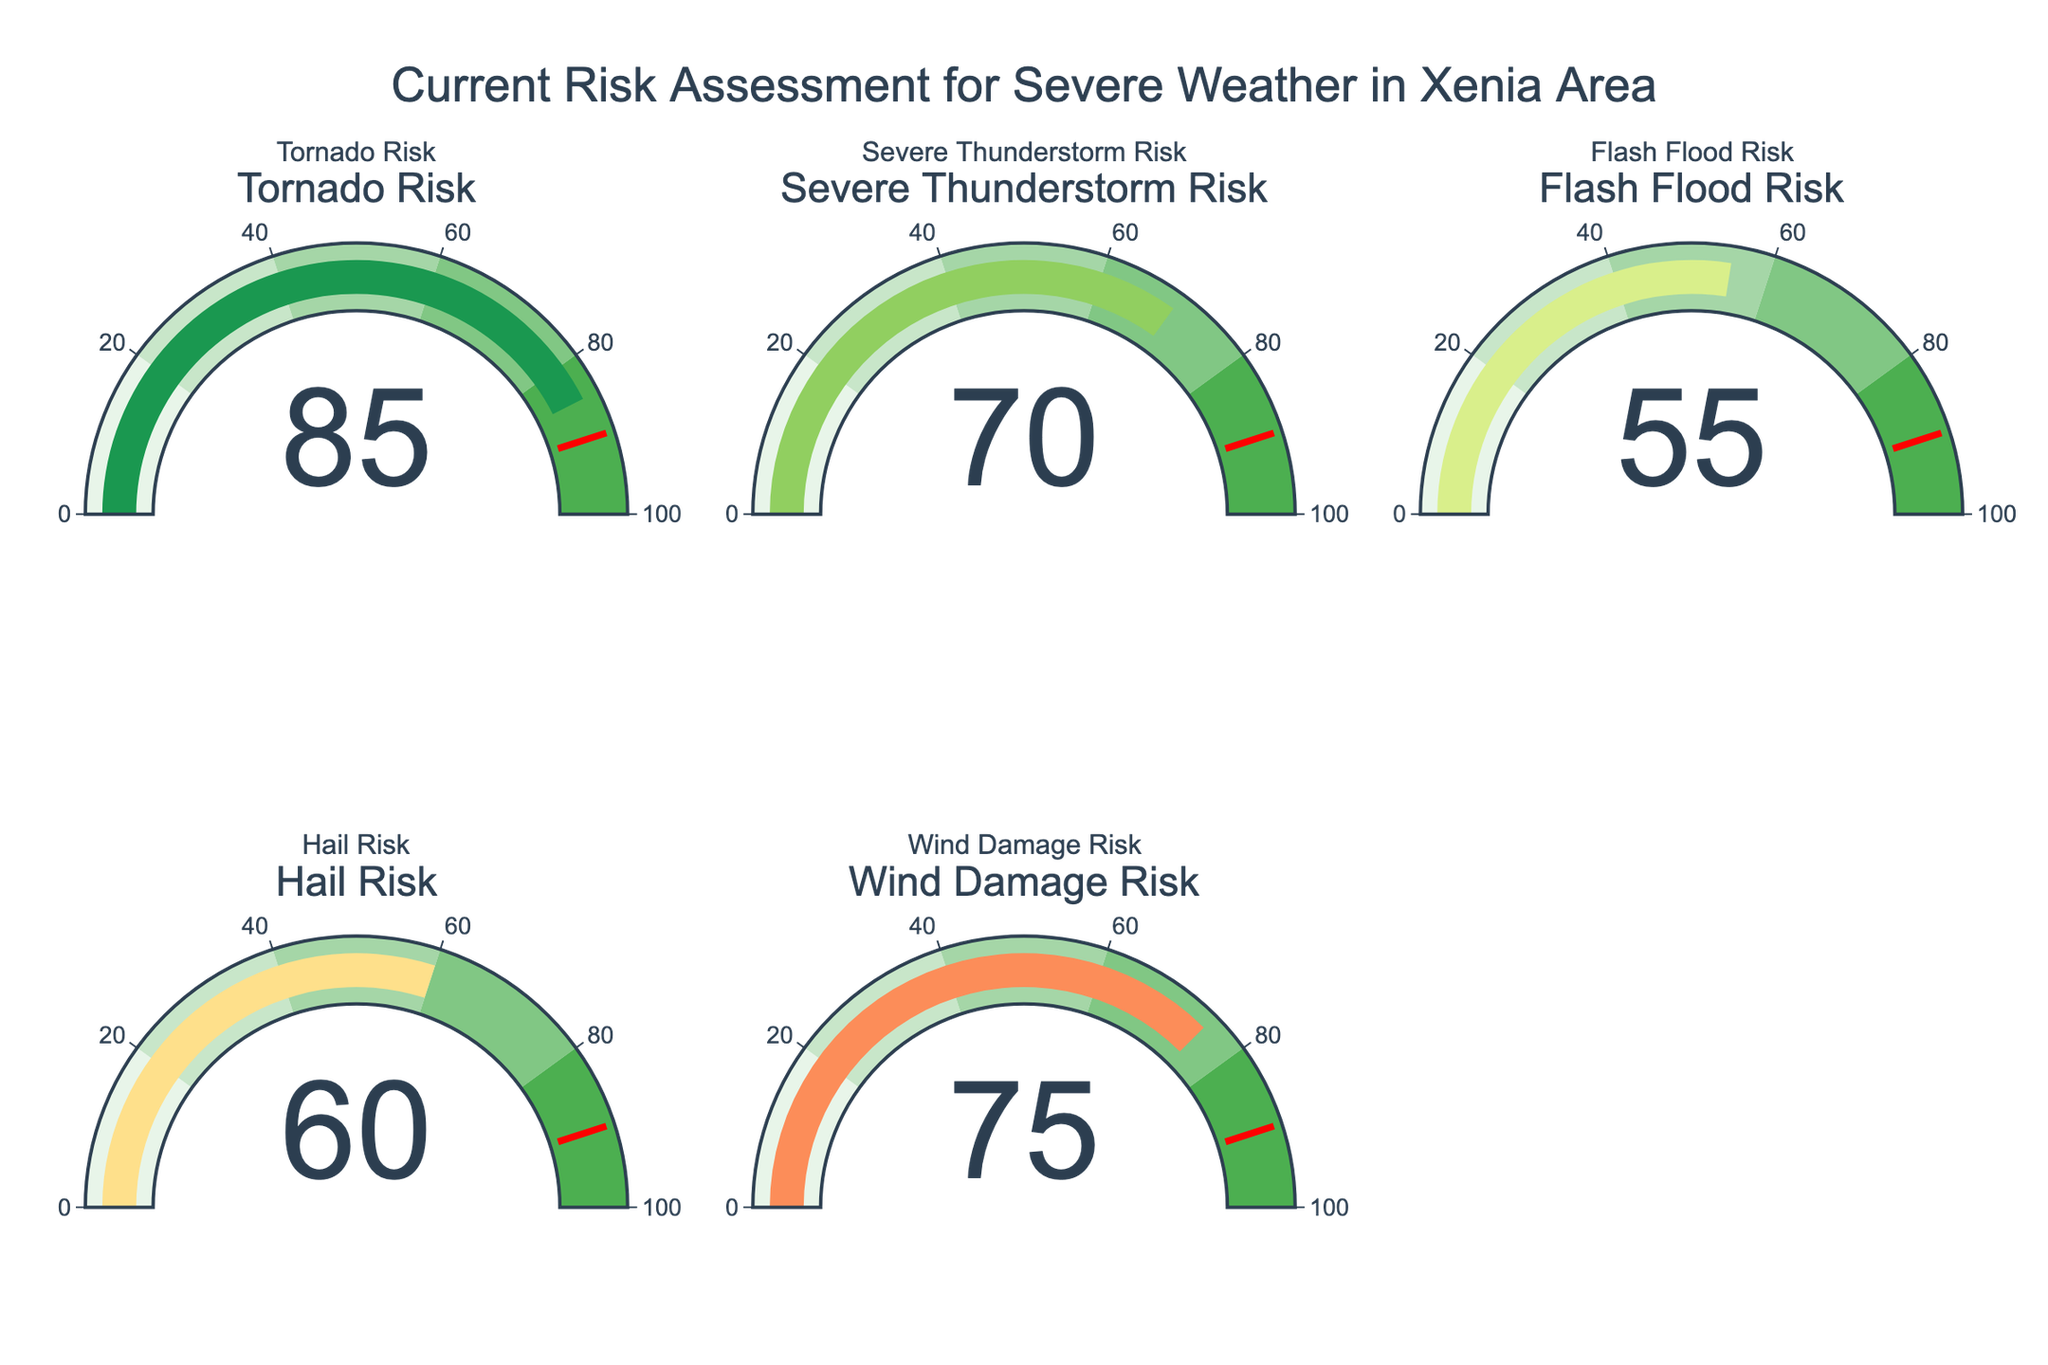How many risk factors are displayed in the figure? Count the number of gauge charts presented in the figure. There are five gauges, each representing a different risk factor.
Answer: 5 What is the title of the figure? Look at the top of the figure, where the title is positioned. The title reads, "Current Risk Assessment for Severe Weather in Xenia Area."
Answer: Current Risk Assessment for Severe Weather in Xenia Area Which risk factor has the highest value? Compare the values shown on each gauge chart. The "Tornado Risk" gauge displays the highest value of 85.
Answer: Tornado Risk How much higher is the Wind Damage Risk compared to the Flash Flood Risk? Subtract the Flash Flood Risk value (55) from the Wind Damage Risk value (75). The difference is 75 - 55 = 20.
Answer: 20 Which color represents the Tornado Risk gauge? Observe the color of the bar in the Tornado Risk gauge. The color is a shade of red.
Answer: Red What's the average value of all the risk assessments? Add up all the displayed values (85 + 70 + 55 + 60 + 75) and divide by the number of gauges (5). The average is (85 + 70 + 55 + 60 + 75)/5 = 69.
Answer: 69 Which risk factor has the second lowest assessment level? Arrange the values in ascending order (55, 60, 70, 75, 85) and identify the second lowest value, which is for "Hail Risk" with a value of 60.
Answer: Hail Risk Are any of the risk factors below 50? Check all the gauge values to see if any are less than 50. All the displayed values are above 50.
Answer: No What is the combined value of Tornado Risk and Hail Risk? Add the values of Tornado Risk (85) and Hail Risk (60). The combined value is 85 + 60 = 145.
Answer: 145 